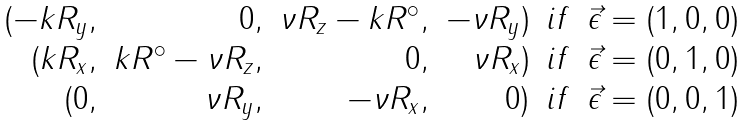<formula> <loc_0><loc_0><loc_500><loc_500>\begin{array} { r r r r c r } ( - k R _ { y } , & 0 , & \nu R _ { z } - k R ^ { \circ } , & - \nu R _ { y } ) & i f & \vec { \epsilon } = ( 1 , 0 , 0 ) \\ ( k R _ { x } , & k R ^ { \circ } - \nu R _ { z } , & 0 , & \nu R _ { x } ) & i f & \vec { \epsilon } = ( 0 , 1 , 0 ) \\ ( 0 , & \nu R _ { y } , & - \nu R _ { x } , & 0 ) & i f & \vec { \epsilon } = ( 0 , 0 , 1 ) \end{array}</formula> 